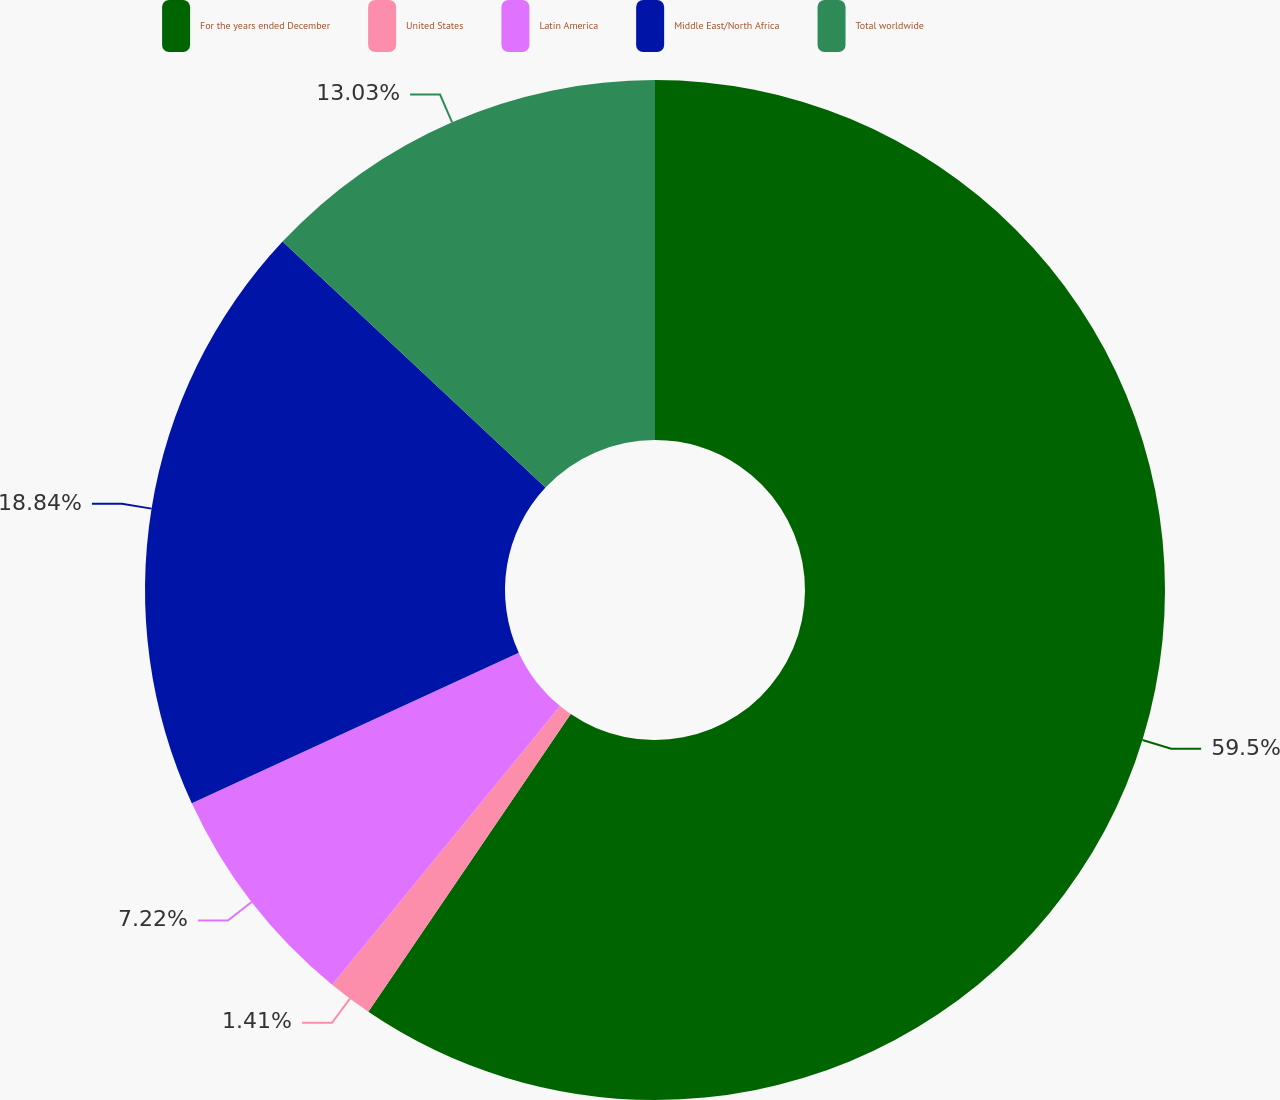<chart> <loc_0><loc_0><loc_500><loc_500><pie_chart><fcel>For the years ended December<fcel>United States<fcel>Latin America<fcel>Middle East/North Africa<fcel>Total worldwide<nl><fcel>59.5%<fcel>1.41%<fcel>7.22%<fcel>18.84%<fcel>13.03%<nl></chart> 